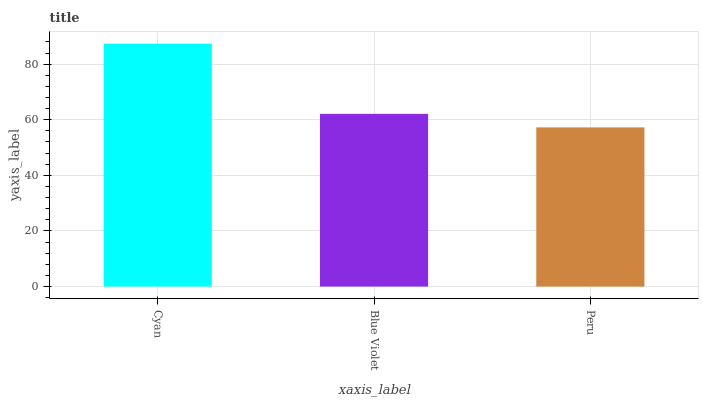Is Peru the minimum?
Answer yes or no. Yes. Is Cyan the maximum?
Answer yes or no. Yes. Is Blue Violet the minimum?
Answer yes or no. No. Is Blue Violet the maximum?
Answer yes or no. No. Is Cyan greater than Blue Violet?
Answer yes or no. Yes. Is Blue Violet less than Cyan?
Answer yes or no. Yes. Is Blue Violet greater than Cyan?
Answer yes or no. No. Is Cyan less than Blue Violet?
Answer yes or no. No. Is Blue Violet the high median?
Answer yes or no. Yes. Is Blue Violet the low median?
Answer yes or no. Yes. Is Peru the high median?
Answer yes or no. No. Is Cyan the low median?
Answer yes or no. No. 